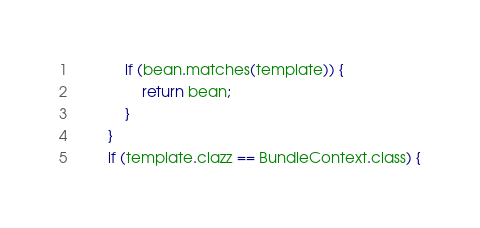<code> <loc_0><loc_0><loc_500><loc_500><_Java_>            if (bean.matches(template)) {
                return bean;
            }
        }
        if (template.clazz == BundleContext.class) {</code> 